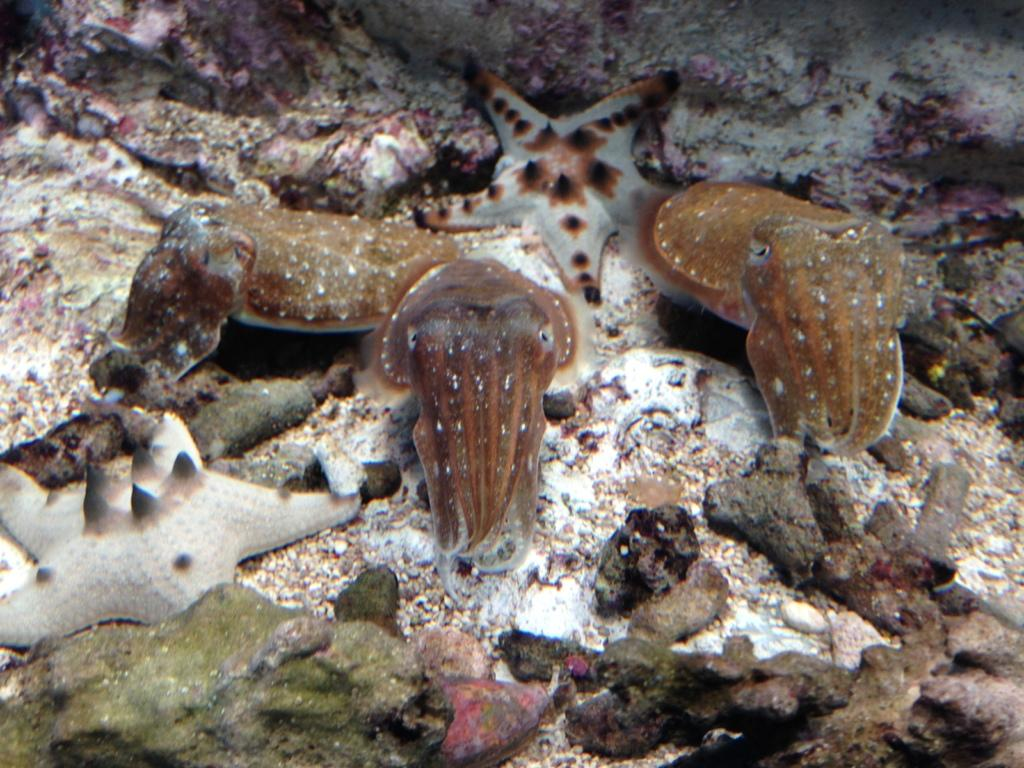What type of environment is depicted in the image? The image is an underwater picture. What types of creatures can be seen in the image? There are aquatic animals in the image. What else can be seen in the underwater environment? There are stones visible in the image. What color is the van parked near the water in the image? There is no van present in the image; it is an underwater picture with no visible land or vehicles. 